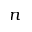Convert formula to latex. <formula><loc_0><loc_0><loc_500><loc_500>n</formula> 